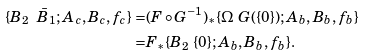<formula> <loc_0><loc_0><loc_500><loc_500>\{ B _ { 2 } \ \bar { B } _ { 1 } ; A _ { c } , B _ { c } , f _ { c } \} = & ( F \circ G ^ { - 1 } ) _ { * } \{ \Omega \ G ( \{ 0 \} ) ; A _ { b } , B _ { b } , f _ { b } \} \\ = & F _ { * } \{ B _ { 2 } \ \{ 0 \} ; A _ { b } , B _ { b } , f _ { b } \} .</formula> 